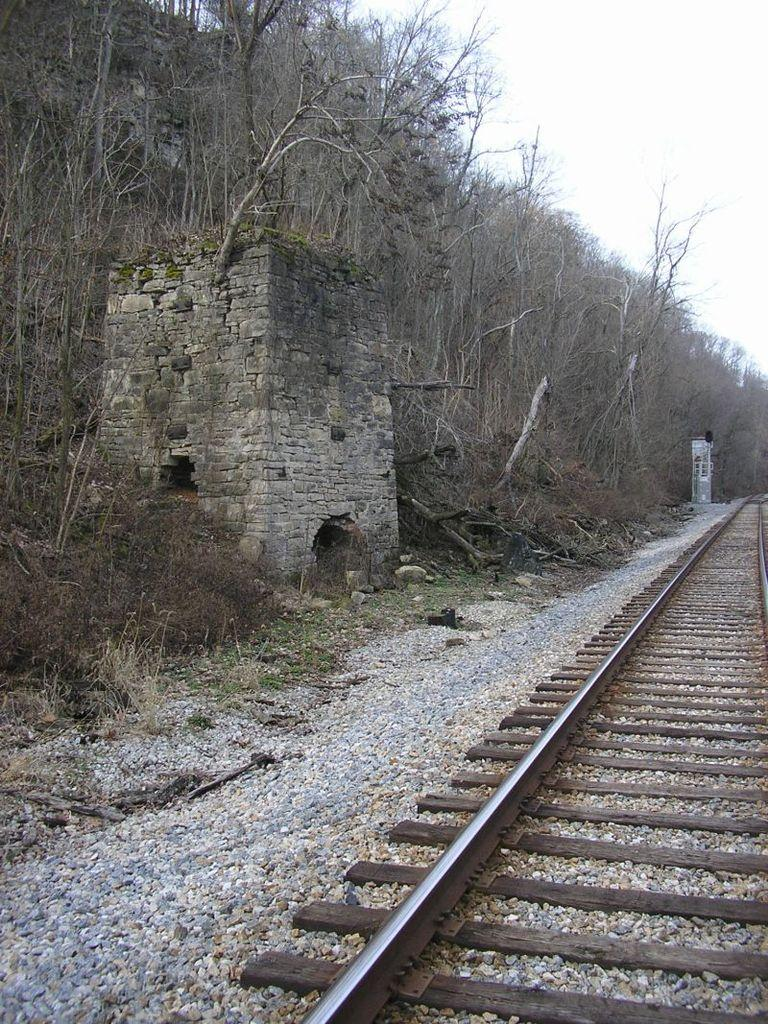What type of structure is present in the image? There is a fort in the image. What else can be seen in the image besides the fort? There is a pole, trees, a track at the bottom, and stones visible in the image. Can you describe the pole in the image? The pole is a vertical structure that stands in the image. What type of terrain is visible in the image? The image shows a combination of natural elements, such as trees, and man-made structures, like the fort and track. What time of day is depicted in the image? The image does not provide any information about the time of day, so it cannot be determined from the image. 